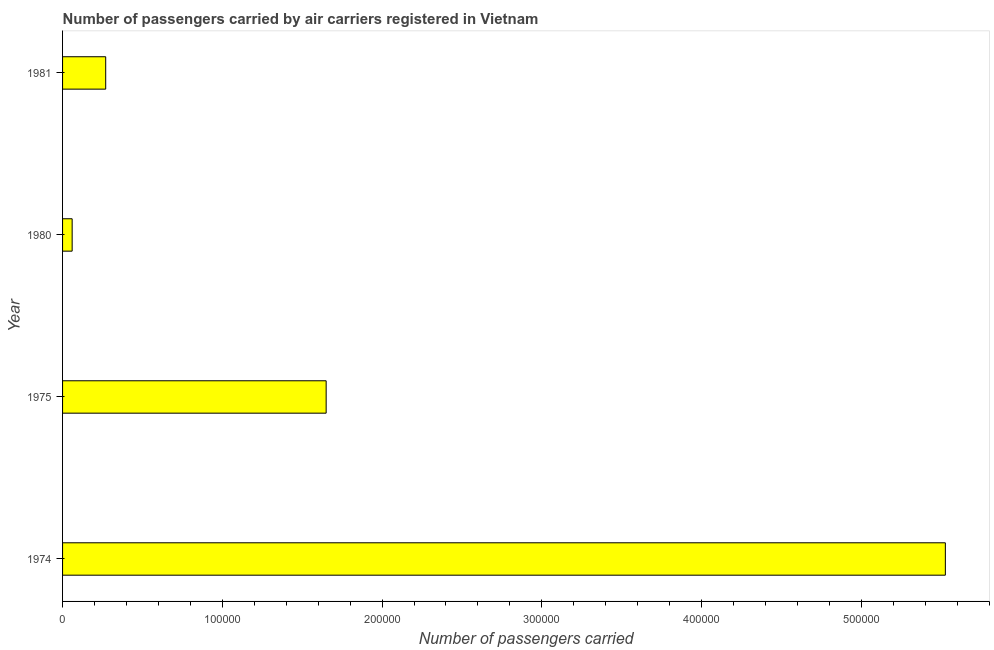Does the graph contain grids?
Give a very brief answer. No. What is the title of the graph?
Ensure brevity in your answer.  Number of passengers carried by air carriers registered in Vietnam. What is the label or title of the X-axis?
Give a very brief answer. Number of passengers carried. What is the label or title of the Y-axis?
Make the answer very short. Year. What is the number of passengers carried in 1975?
Offer a very short reply. 1.65e+05. Across all years, what is the maximum number of passengers carried?
Offer a very short reply. 5.53e+05. Across all years, what is the minimum number of passengers carried?
Ensure brevity in your answer.  6000. In which year was the number of passengers carried maximum?
Your response must be concise. 1974. In which year was the number of passengers carried minimum?
Provide a succinct answer. 1980. What is the sum of the number of passengers carried?
Your response must be concise. 7.51e+05. What is the difference between the number of passengers carried in 1974 and 1981?
Give a very brief answer. 5.26e+05. What is the average number of passengers carried per year?
Offer a terse response. 1.88e+05. What is the median number of passengers carried?
Give a very brief answer. 9.60e+04. In how many years, is the number of passengers carried greater than 240000 ?
Your response must be concise. 1. Do a majority of the years between 1980 and 1981 (inclusive) have number of passengers carried greater than 380000 ?
Your answer should be compact. No. What is the ratio of the number of passengers carried in 1974 to that in 1980?
Provide a succinct answer. 92.1. Is the number of passengers carried in 1975 less than that in 1980?
Your answer should be compact. No. What is the difference between the highest and the second highest number of passengers carried?
Provide a succinct answer. 3.88e+05. What is the difference between the highest and the lowest number of passengers carried?
Give a very brief answer. 5.47e+05. Are all the bars in the graph horizontal?
Give a very brief answer. Yes. What is the difference between two consecutive major ticks on the X-axis?
Provide a succinct answer. 1.00e+05. What is the Number of passengers carried of 1974?
Your answer should be compact. 5.53e+05. What is the Number of passengers carried in 1975?
Make the answer very short. 1.65e+05. What is the Number of passengers carried in 1980?
Provide a succinct answer. 6000. What is the Number of passengers carried of 1981?
Your answer should be very brief. 2.70e+04. What is the difference between the Number of passengers carried in 1974 and 1975?
Keep it short and to the point. 3.88e+05. What is the difference between the Number of passengers carried in 1974 and 1980?
Provide a short and direct response. 5.47e+05. What is the difference between the Number of passengers carried in 1974 and 1981?
Make the answer very short. 5.26e+05. What is the difference between the Number of passengers carried in 1975 and 1980?
Offer a very short reply. 1.59e+05. What is the difference between the Number of passengers carried in 1975 and 1981?
Your answer should be compact. 1.38e+05. What is the difference between the Number of passengers carried in 1980 and 1981?
Provide a succinct answer. -2.10e+04. What is the ratio of the Number of passengers carried in 1974 to that in 1975?
Keep it short and to the point. 3.35. What is the ratio of the Number of passengers carried in 1974 to that in 1980?
Your answer should be compact. 92.1. What is the ratio of the Number of passengers carried in 1974 to that in 1981?
Your response must be concise. 20.47. What is the ratio of the Number of passengers carried in 1975 to that in 1981?
Provide a short and direct response. 6.11. What is the ratio of the Number of passengers carried in 1980 to that in 1981?
Your answer should be very brief. 0.22. 